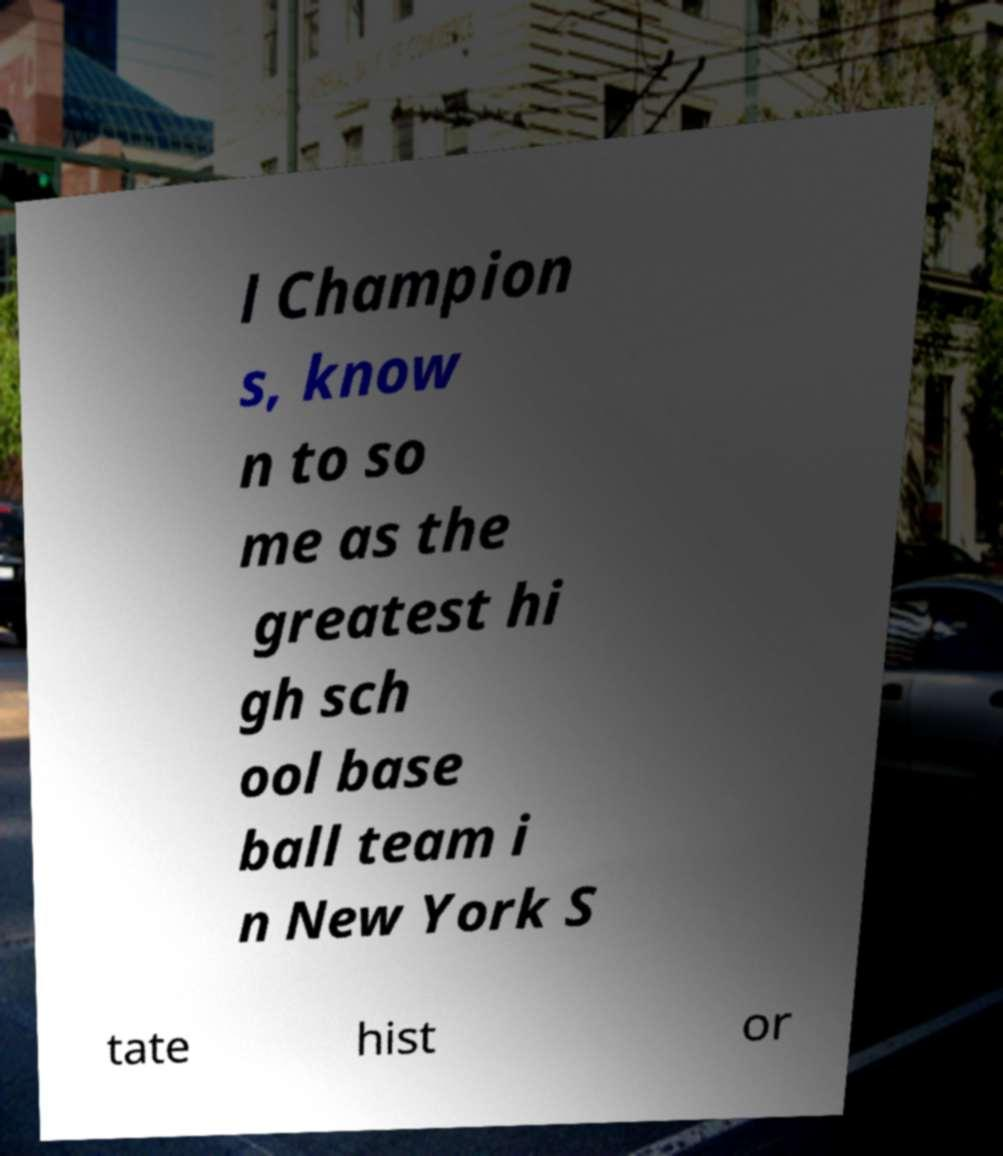I need the written content from this picture converted into text. Can you do that? l Champion s, know n to so me as the greatest hi gh sch ool base ball team i n New York S tate hist or 